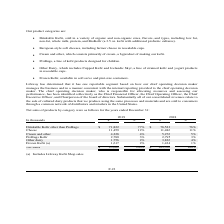From Lifeway Foods's financial document, What is net sales from cheese in 2018 and 2019 respectively? The document shows two values: 11,486 and 11,459 (in thousands). From the document: "Cheese 11,459 12% 11,486 11% Cheese 11,459 12% 11,486 11%..." Also, What is net sales from cream and other in 2018 and 2019 respectively? The document shows two values: 5,276 and 4,228 (in thousands). From the document: "Cream and other 4,228 4% 5,276 5% Cream and other 4,228 4% 5,276 5%..." Also, What is net sales from ProBugs Kefir in 2018 and 2019 respectively? The document shows two values: 2,795 and 2,780 (in thousands). From the document: "ProBugs Kefir 2,780 3% 2,795 3% ProBugs Kefir 2,780 3% 2,795 3%..." Also, How many product categories are available? Counting the relevant items in the document: Drinkable Kefir other than ProBugs ,  Cheese ,  Cream and other ,  ProBugs Kefir ,  Other dairy ,  Frozen Kefir, I find 6 instances. The key data points involved are: Cheese, Cream and other, Drinkable Kefir other than ProBugs. Also, can you calculate: What is the change in the net sales for cheese between 2018 and 2019? Based on the calculation:  11,459 - 11,486 , the result is -27 (in thousands). This is based on the information: "Cheese 11,459 12% 11,486 11% Cheese 11,459 12% 11,486 11%..." The key data points involved are: 11,459, 11,486. Also, can you calculate: What is the percentage change in net sales from Frozen Kefir between 2018 and 2019? To answer this question, I need to perform calculations using the financial data. The calculation is: (1,617-1,434)/1,434, which equals 12.76 (percentage). This is based on the information: "Frozen Kefir (a) 1,617 2% 1,434 1% Frozen Kefir (a) 1,617 2% 1,434 1%..." The key data points involved are: 1,434, 1,617. 